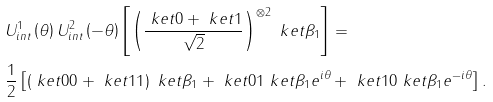<formula> <loc_0><loc_0><loc_500><loc_500>& U _ { i n t } ^ { 1 } \left ( \theta \right ) U _ { i n t } ^ { 2 } \left ( - \theta \right ) \left [ \left ( \frac { \ k e t { 0 } + \ k e t { 1 } } { \sqrt { 2 } } \right ) ^ { \otimes 2 } \ k e t { \beta _ { 1 } } \right ] = \\ & \frac { 1 } { 2 } \left [ \left ( \ k e t { 0 0 } + \ k e t { 1 1 } \right ) \ k e t { \beta _ { 1 } } + \ k e t { 0 1 } \ k e t { \beta _ { 1 } e ^ { i \theta } } + \ k e t { 1 0 } \ k e t { \beta _ { 1 } e ^ { - i \theta } } \right ] .</formula> 